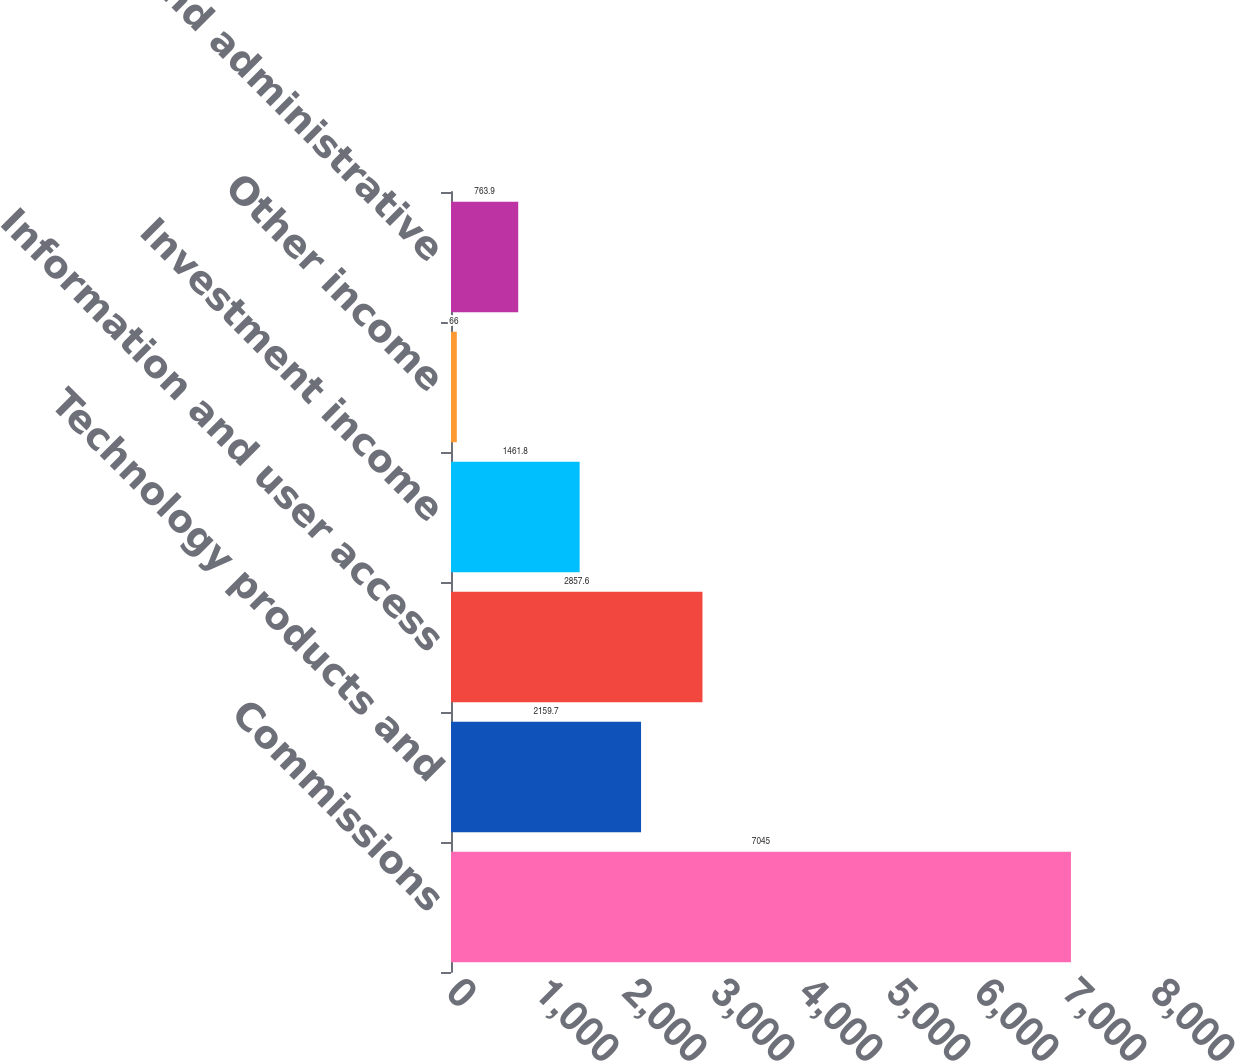Convert chart. <chart><loc_0><loc_0><loc_500><loc_500><bar_chart><fcel>Commissions<fcel>Technology products and<fcel>Information and user access<fcel>Investment income<fcel>Other income<fcel>General and administrative<nl><fcel>7045<fcel>2159.7<fcel>2857.6<fcel>1461.8<fcel>66<fcel>763.9<nl></chart> 